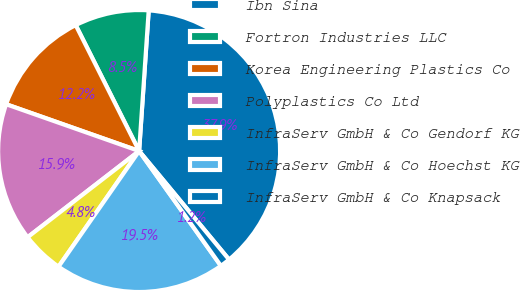Convert chart to OTSL. <chart><loc_0><loc_0><loc_500><loc_500><pie_chart><fcel>Ibn Sina<fcel>Fortron Industries LLC<fcel>Korea Engineering Plastics Co<fcel>Polyplastics Co Ltd<fcel>InfraServ GmbH & Co Gendorf KG<fcel>InfraServ GmbH & Co Hoechst KG<fcel>InfraServ GmbH & Co Knapsack<nl><fcel>37.91%<fcel>8.51%<fcel>12.19%<fcel>15.86%<fcel>4.84%<fcel>19.54%<fcel>1.16%<nl></chart> 